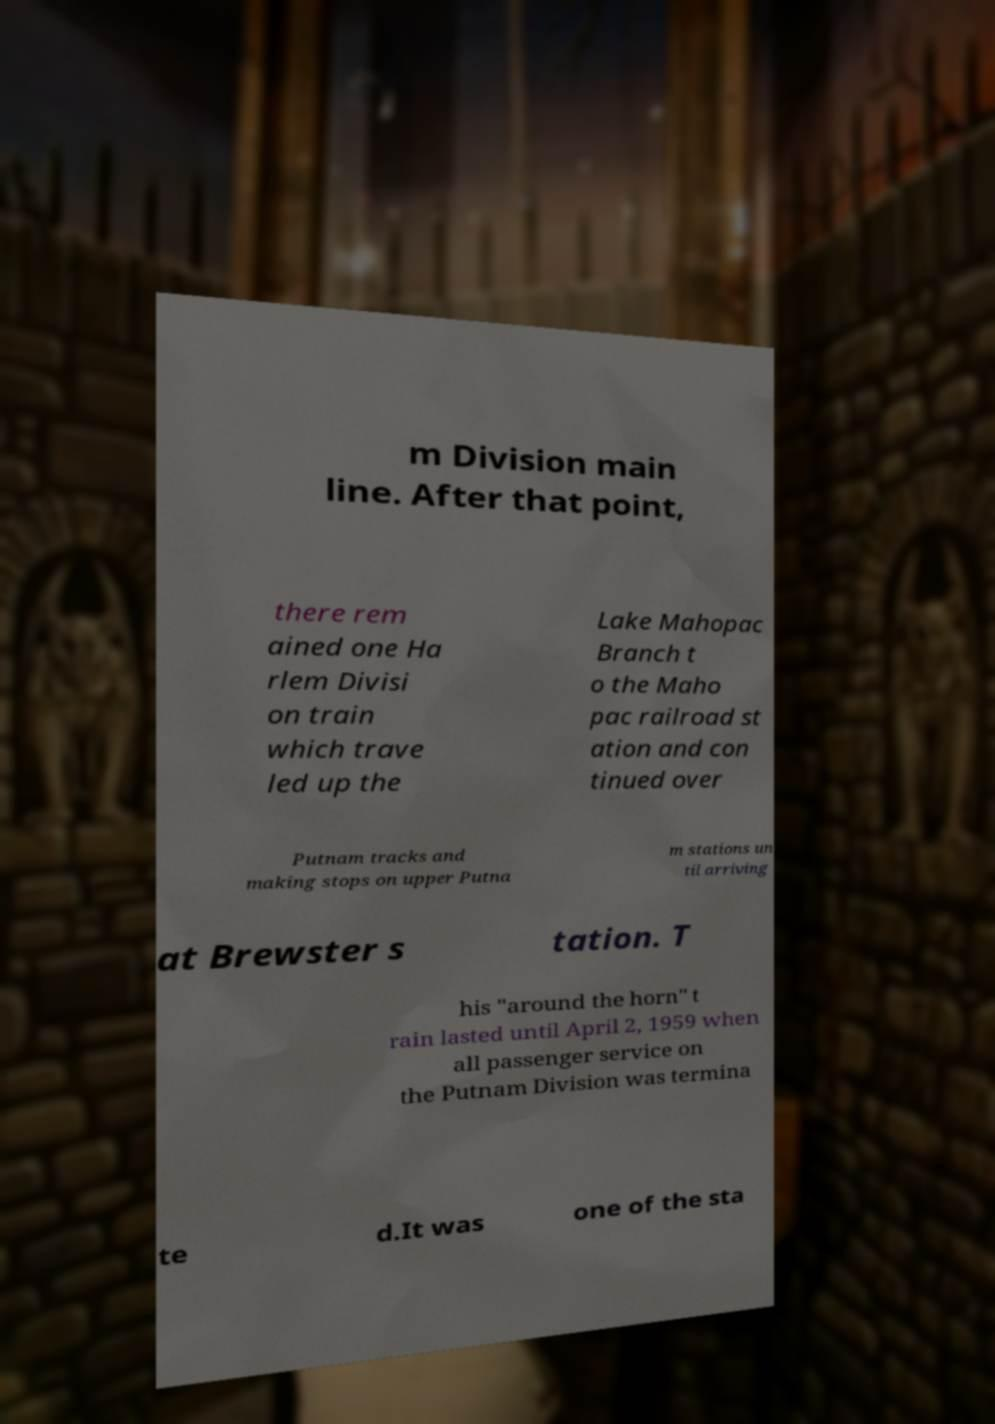Please identify and transcribe the text found in this image. m Division main line. After that point, there rem ained one Ha rlem Divisi on train which trave led up the Lake Mahopac Branch t o the Maho pac railroad st ation and con tinued over Putnam tracks and making stops on upper Putna m stations un til arriving at Brewster s tation. T his "around the horn" t rain lasted until April 2, 1959 when all passenger service on the Putnam Division was termina te d.It was one of the sta 